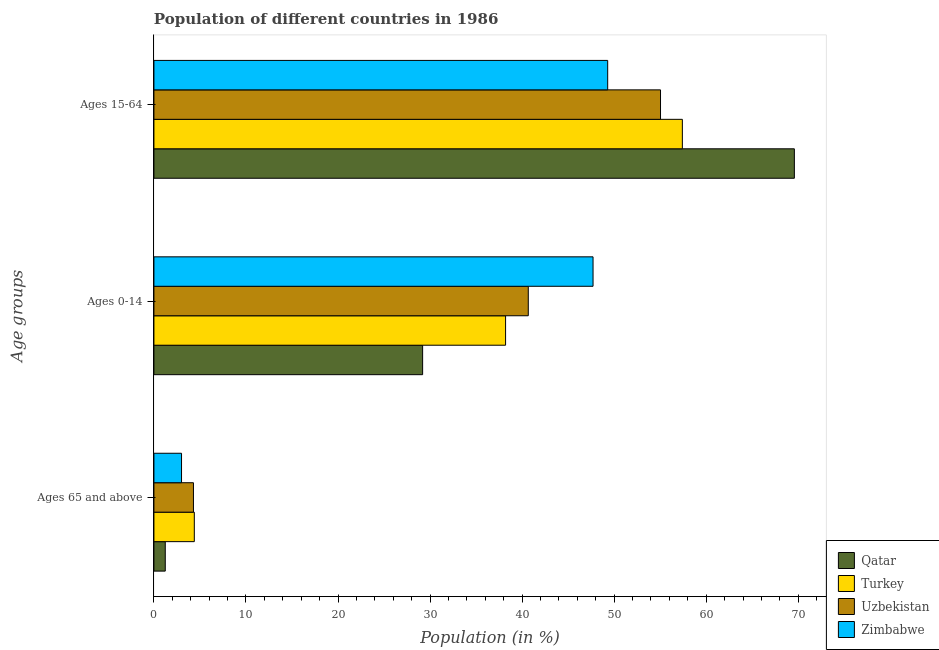How many different coloured bars are there?
Your answer should be very brief. 4. How many groups of bars are there?
Ensure brevity in your answer.  3. How many bars are there on the 1st tick from the top?
Offer a terse response. 4. How many bars are there on the 2nd tick from the bottom?
Make the answer very short. 4. What is the label of the 3rd group of bars from the top?
Offer a very short reply. Ages 65 and above. What is the percentage of population within the age-group 0-14 in Uzbekistan?
Your answer should be very brief. 40.67. Across all countries, what is the maximum percentage of population within the age-group 15-64?
Your response must be concise. 69.58. Across all countries, what is the minimum percentage of population within the age-group 0-14?
Ensure brevity in your answer.  29.19. In which country was the percentage of population within the age-group 15-64 maximum?
Your answer should be compact. Qatar. In which country was the percentage of population within the age-group of 65 and above minimum?
Offer a very short reply. Qatar. What is the total percentage of population within the age-group 15-64 in the graph?
Ensure brevity in your answer.  231.32. What is the difference between the percentage of population within the age-group 0-14 in Uzbekistan and that in Zimbabwe?
Your response must be concise. -7.04. What is the difference between the percentage of population within the age-group 15-64 in Qatar and the percentage of population within the age-group 0-14 in Uzbekistan?
Your answer should be compact. 28.91. What is the average percentage of population within the age-group 15-64 per country?
Your answer should be compact. 57.83. What is the difference between the percentage of population within the age-group of 65 and above and percentage of population within the age-group 0-14 in Turkey?
Your response must be concise. -33.82. In how many countries, is the percentage of population within the age-group 15-64 greater than 12 %?
Make the answer very short. 4. What is the ratio of the percentage of population within the age-group of 65 and above in Qatar to that in Uzbekistan?
Provide a short and direct response. 0.29. Is the percentage of population within the age-group 15-64 in Zimbabwe less than that in Turkey?
Provide a short and direct response. Yes. Is the difference between the percentage of population within the age-group of 65 and above in Qatar and Zimbabwe greater than the difference between the percentage of population within the age-group 15-64 in Qatar and Zimbabwe?
Ensure brevity in your answer.  No. What is the difference between the highest and the second highest percentage of population within the age-group 15-64?
Your answer should be very brief. 12.17. What is the difference between the highest and the lowest percentage of population within the age-group 15-64?
Provide a short and direct response. 20.28. In how many countries, is the percentage of population within the age-group of 65 and above greater than the average percentage of population within the age-group of 65 and above taken over all countries?
Provide a succinct answer. 2. What does the 2nd bar from the top in Ages 15-64 represents?
Offer a terse response. Uzbekistan. What does the 3rd bar from the bottom in Ages 0-14 represents?
Your answer should be compact. Uzbekistan. Is it the case that in every country, the sum of the percentage of population within the age-group of 65 and above and percentage of population within the age-group 0-14 is greater than the percentage of population within the age-group 15-64?
Provide a succinct answer. No. What is the difference between two consecutive major ticks on the X-axis?
Keep it short and to the point. 10. Are the values on the major ticks of X-axis written in scientific E-notation?
Your answer should be very brief. No. Does the graph contain any zero values?
Your response must be concise. No. Does the graph contain grids?
Your answer should be very brief. No. How many legend labels are there?
Provide a short and direct response. 4. How are the legend labels stacked?
Keep it short and to the point. Vertical. What is the title of the graph?
Offer a very short reply. Population of different countries in 1986. What is the label or title of the X-axis?
Your answer should be very brief. Population (in %). What is the label or title of the Y-axis?
Your answer should be compact. Age groups. What is the Population (in %) in Qatar in Ages 65 and above?
Your answer should be very brief. 1.23. What is the Population (in %) in Turkey in Ages 65 and above?
Your answer should be very brief. 4.39. What is the Population (in %) of Uzbekistan in Ages 65 and above?
Keep it short and to the point. 4.29. What is the Population (in %) of Zimbabwe in Ages 65 and above?
Offer a terse response. 3. What is the Population (in %) of Qatar in Ages 0-14?
Provide a succinct answer. 29.19. What is the Population (in %) in Turkey in Ages 0-14?
Make the answer very short. 38.2. What is the Population (in %) of Uzbekistan in Ages 0-14?
Your response must be concise. 40.67. What is the Population (in %) of Zimbabwe in Ages 0-14?
Your response must be concise. 47.71. What is the Population (in %) in Qatar in Ages 15-64?
Ensure brevity in your answer.  69.58. What is the Population (in %) in Turkey in Ages 15-64?
Your answer should be very brief. 57.41. What is the Population (in %) in Uzbekistan in Ages 15-64?
Your answer should be compact. 55.04. What is the Population (in %) of Zimbabwe in Ages 15-64?
Ensure brevity in your answer.  49.3. Across all Age groups, what is the maximum Population (in %) of Qatar?
Your answer should be very brief. 69.58. Across all Age groups, what is the maximum Population (in %) of Turkey?
Provide a succinct answer. 57.41. Across all Age groups, what is the maximum Population (in %) of Uzbekistan?
Offer a terse response. 55.04. Across all Age groups, what is the maximum Population (in %) of Zimbabwe?
Offer a terse response. 49.3. Across all Age groups, what is the minimum Population (in %) of Qatar?
Ensure brevity in your answer.  1.23. Across all Age groups, what is the minimum Population (in %) in Turkey?
Ensure brevity in your answer.  4.39. Across all Age groups, what is the minimum Population (in %) of Uzbekistan?
Your response must be concise. 4.29. Across all Age groups, what is the minimum Population (in %) of Zimbabwe?
Give a very brief answer. 3. What is the total Population (in %) in Turkey in the graph?
Ensure brevity in your answer.  100. What is the total Population (in %) of Uzbekistan in the graph?
Ensure brevity in your answer.  100. What is the total Population (in %) of Zimbabwe in the graph?
Ensure brevity in your answer.  100. What is the difference between the Population (in %) of Qatar in Ages 65 and above and that in Ages 0-14?
Give a very brief answer. -27.96. What is the difference between the Population (in %) in Turkey in Ages 65 and above and that in Ages 0-14?
Offer a very short reply. -33.82. What is the difference between the Population (in %) in Uzbekistan in Ages 65 and above and that in Ages 0-14?
Keep it short and to the point. -36.38. What is the difference between the Population (in %) in Zimbabwe in Ages 65 and above and that in Ages 0-14?
Keep it short and to the point. -44.71. What is the difference between the Population (in %) of Qatar in Ages 65 and above and that in Ages 15-64?
Ensure brevity in your answer.  -68.34. What is the difference between the Population (in %) of Turkey in Ages 65 and above and that in Ages 15-64?
Ensure brevity in your answer.  -53.02. What is the difference between the Population (in %) in Uzbekistan in Ages 65 and above and that in Ages 15-64?
Make the answer very short. -50.74. What is the difference between the Population (in %) in Zimbabwe in Ages 65 and above and that in Ages 15-64?
Provide a succinct answer. -46.3. What is the difference between the Population (in %) of Qatar in Ages 0-14 and that in Ages 15-64?
Give a very brief answer. -40.38. What is the difference between the Population (in %) in Turkey in Ages 0-14 and that in Ages 15-64?
Provide a short and direct response. -19.2. What is the difference between the Population (in %) of Uzbekistan in Ages 0-14 and that in Ages 15-64?
Give a very brief answer. -14.37. What is the difference between the Population (in %) of Zimbabwe in Ages 0-14 and that in Ages 15-64?
Keep it short and to the point. -1.59. What is the difference between the Population (in %) in Qatar in Ages 65 and above and the Population (in %) in Turkey in Ages 0-14?
Make the answer very short. -36.97. What is the difference between the Population (in %) of Qatar in Ages 65 and above and the Population (in %) of Uzbekistan in Ages 0-14?
Ensure brevity in your answer.  -39.44. What is the difference between the Population (in %) of Qatar in Ages 65 and above and the Population (in %) of Zimbabwe in Ages 0-14?
Give a very brief answer. -46.47. What is the difference between the Population (in %) in Turkey in Ages 65 and above and the Population (in %) in Uzbekistan in Ages 0-14?
Provide a succinct answer. -36.28. What is the difference between the Population (in %) of Turkey in Ages 65 and above and the Population (in %) of Zimbabwe in Ages 0-14?
Offer a terse response. -43.32. What is the difference between the Population (in %) of Uzbekistan in Ages 65 and above and the Population (in %) of Zimbabwe in Ages 0-14?
Give a very brief answer. -43.41. What is the difference between the Population (in %) in Qatar in Ages 65 and above and the Population (in %) in Turkey in Ages 15-64?
Provide a short and direct response. -56.18. What is the difference between the Population (in %) in Qatar in Ages 65 and above and the Population (in %) in Uzbekistan in Ages 15-64?
Your answer should be compact. -53.8. What is the difference between the Population (in %) in Qatar in Ages 65 and above and the Population (in %) in Zimbabwe in Ages 15-64?
Provide a short and direct response. -48.06. What is the difference between the Population (in %) of Turkey in Ages 65 and above and the Population (in %) of Uzbekistan in Ages 15-64?
Your answer should be compact. -50.65. What is the difference between the Population (in %) of Turkey in Ages 65 and above and the Population (in %) of Zimbabwe in Ages 15-64?
Your response must be concise. -44.91. What is the difference between the Population (in %) in Uzbekistan in Ages 65 and above and the Population (in %) in Zimbabwe in Ages 15-64?
Provide a succinct answer. -45. What is the difference between the Population (in %) of Qatar in Ages 0-14 and the Population (in %) of Turkey in Ages 15-64?
Give a very brief answer. -28.22. What is the difference between the Population (in %) in Qatar in Ages 0-14 and the Population (in %) in Uzbekistan in Ages 15-64?
Your answer should be compact. -25.84. What is the difference between the Population (in %) of Qatar in Ages 0-14 and the Population (in %) of Zimbabwe in Ages 15-64?
Offer a very short reply. -20.11. What is the difference between the Population (in %) of Turkey in Ages 0-14 and the Population (in %) of Uzbekistan in Ages 15-64?
Your answer should be compact. -16.83. What is the difference between the Population (in %) in Turkey in Ages 0-14 and the Population (in %) in Zimbabwe in Ages 15-64?
Your answer should be very brief. -11.09. What is the difference between the Population (in %) in Uzbekistan in Ages 0-14 and the Population (in %) in Zimbabwe in Ages 15-64?
Keep it short and to the point. -8.63. What is the average Population (in %) in Qatar per Age groups?
Provide a short and direct response. 33.33. What is the average Population (in %) in Turkey per Age groups?
Give a very brief answer. 33.33. What is the average Population (in %) in Uzbekistan per Age groups?
Offer a terse response. 33.33. What is the average Population (in %) in Zimbabwe per Age groups?
Your response must be concise. 33.33. What is the difference between the Population (in %) of Qatar and Population (in %) of Turkey in Ages 65 and above?
Provide a succinct answer. -3.16. What is the difference between the Population (in %) in Qatar and Population (in %) in Uzbekistan in Ages 65 and above?
Give a very brief answer. -3.06. What is the difference between the Population (in %) in Qatar and Population (in %) in Zimbabwe in Ages 65 and above?
Provide a succinct answer. -1.77. What is the difference between the Population (in %) in Turkey and Population (in %) in Uzbekistan in Ages 65 and above?
Offer a terse response. 0.09. What is the difference between the Population (in %) in Turkey and Population (in %) in Zimbabwe in Ages 65 and above?
Keep it short and to the point. 1.39. What is the difference between the Population (in %) in Uzbekistan and Population (in %) in Zimbabwe in Ages 65 and above?
Keep it short and to the point. 1.3. What is the difference between the Population (in %) in Qatar and Population (in %) in Turkey in Ages 0-14?
Provide a short and direct response. -9.01. What is the difference between the Population (in %) in Qatar and Population (in %) in Uzbekistan in Ages 0-14?
Provide a succinct answer. -11.48. What is the difference between the Population (in %) in Qatar and Population (in %) in Zimbabwe in Ages 0-14?
Make the answer very short. -18.51. What is the difference between the Population (in %) in Turkey and Population (in %) in Uzbekistan in Ages 0-14?
Your answer should be very brief. -2.47. What is the difference between the Population (in %) in Turkey and Population (in %) in Zimbabwe in Ages 0-14?
Provide a short and direct response. -9.5. What is the difference between the Population (in %) of Uzbekistan and Population (in %) of Zimbabwe in Ages 0-14?
Your response must be concise. -7.04. What is the difference between the Population (in %) in Qatar and Population (in %) in Turkey in Ages 15-64?
Keep it short and to the point. 12.17. What is the difference between the Population (in %) in Qatar and Population (in %) in Uzbekistan in Ages 15-64?
Offer a very short reply. 14.54. What is the difference between the Population (in %) of Qatar and Population (in %) of Zimbabwe in Ages 15-64?
Ensure brevity in your answer.  20.28. What is the difference between the Population (in %) in Turkey and Population (in %) in Uzbekistan in Ages 15-64?
Your response must be concise. 2.37. What is the difference between the Population (in %) in Turkey and Population (in %) in Zimbabwe in Ages 15-64?
Make the answer very short. 8.11. What is the difference between the Population (in %) in Uzbekistan and Population (in %) in Zimbabwe in Ages 15-64?
Your answer should be compact. 5.74. What is the ratio of the Population (in %) in Qatar in Ages 65 and above to that in Ages 0-14?
Ensure brevity in your answer.  0.04. What is the ratio of the Population (in %) in Turkey in Ages 65 and above to that in Ages 0-14?
Make the answer very short. 0.11. What is the ratio of the Population (in %) in Uzbekistan in Ages 65 and above to that in Ages 0-14?
Offer a very short reply. 0.11. What is the ratio of the Population (in %) of Zimbabwe in Ages 65 and above to that in Ages 0-14?
Provide a succinct answer. 0.06. What is the ratio of the Population (in %) of Qatar in Ages 65 and above to that in Ages 15-64?
Make the answer very short. 0.02. What is the ratio of the Population (in %) in Turkey in Ages 65 and above to that in Ages 15-64?
Provide a succinct answer. 0.08. What is the ratio of the Population (in %) in Uzbekistan in Ages 65 and above to that in Ages 15-64?
Offer a terse response. 0.08. What is the ratio of the Population (in %) in Zimbabwe in Ages 65 and above to that in Ages 15-64?
Offer a very short reply. 0.06. What is the ratio of the Population (in %) of Qatar in Ages 0-14 to that in Ages 15-64?
Provide a short and direct response. 0.42. What is the ratio of the Population (in %) in Turkey in Ages 0-14 to that in Ages 15-64?
Ensure brevity in your answer.  0.67. What is the ratio of the Population (in %) in Uzbekistan in Ages 0-14 to that in Ages 15-64?
Make the answer very short. 0.74. What is the ratio of the Population (in %) in Zimbabwe in Ages 0-14 to that in Ages 15-64?
Give a very brief answer. 0.97. What is the difference between the highest and the second highest Population (in %) in Qatar?
Ensure brevity in your answer.  40.38. What is the difference between the highest and the second highest Population (in %) in Turkey?
Your answer should be compact. 19.2. What is the difference between the highest and the second highest Population (in %) in Uzbekistan?
Provide a succinct answer. 14.37. What is the difference between the highest and the second highest Population (in %) in Zimbabwe?
Keep it short and to the point. 1.59. What is the difference between the highest and the lowest Population (in %) in Qatar?
Provide a short and direct response. 68.34. What is the difference between the highest and the lowest Population (in %) of Turkey?
Your response must be concise. 53.02. What is the difference between the highest and the lowest Population (in %) in Uzbekistan?
Offer a very short reply. 50.74. What is the difference between the highest and the lowest Population (in %) of Zimbabwe?
Your response must be concise. 46.3. 